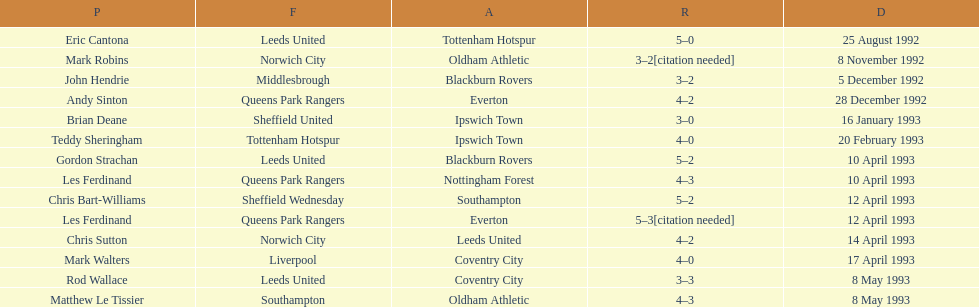Who are the players in 1992-93 fa premier league? Eric Cantona, Mark Robins, John Hendrie, Andy Sinton, Brian Deane, Teddy Sheringham, Gordon Strachan, Les Ferdinand, Chris Bart-Williams, Les Ferdinand, Chris Sutton, Mark Walters, Rod Wallace, Matthew Le Tissier. What is mark robins' result? 3–2[citation needed]. Which player has the same result? John Hendrie. 